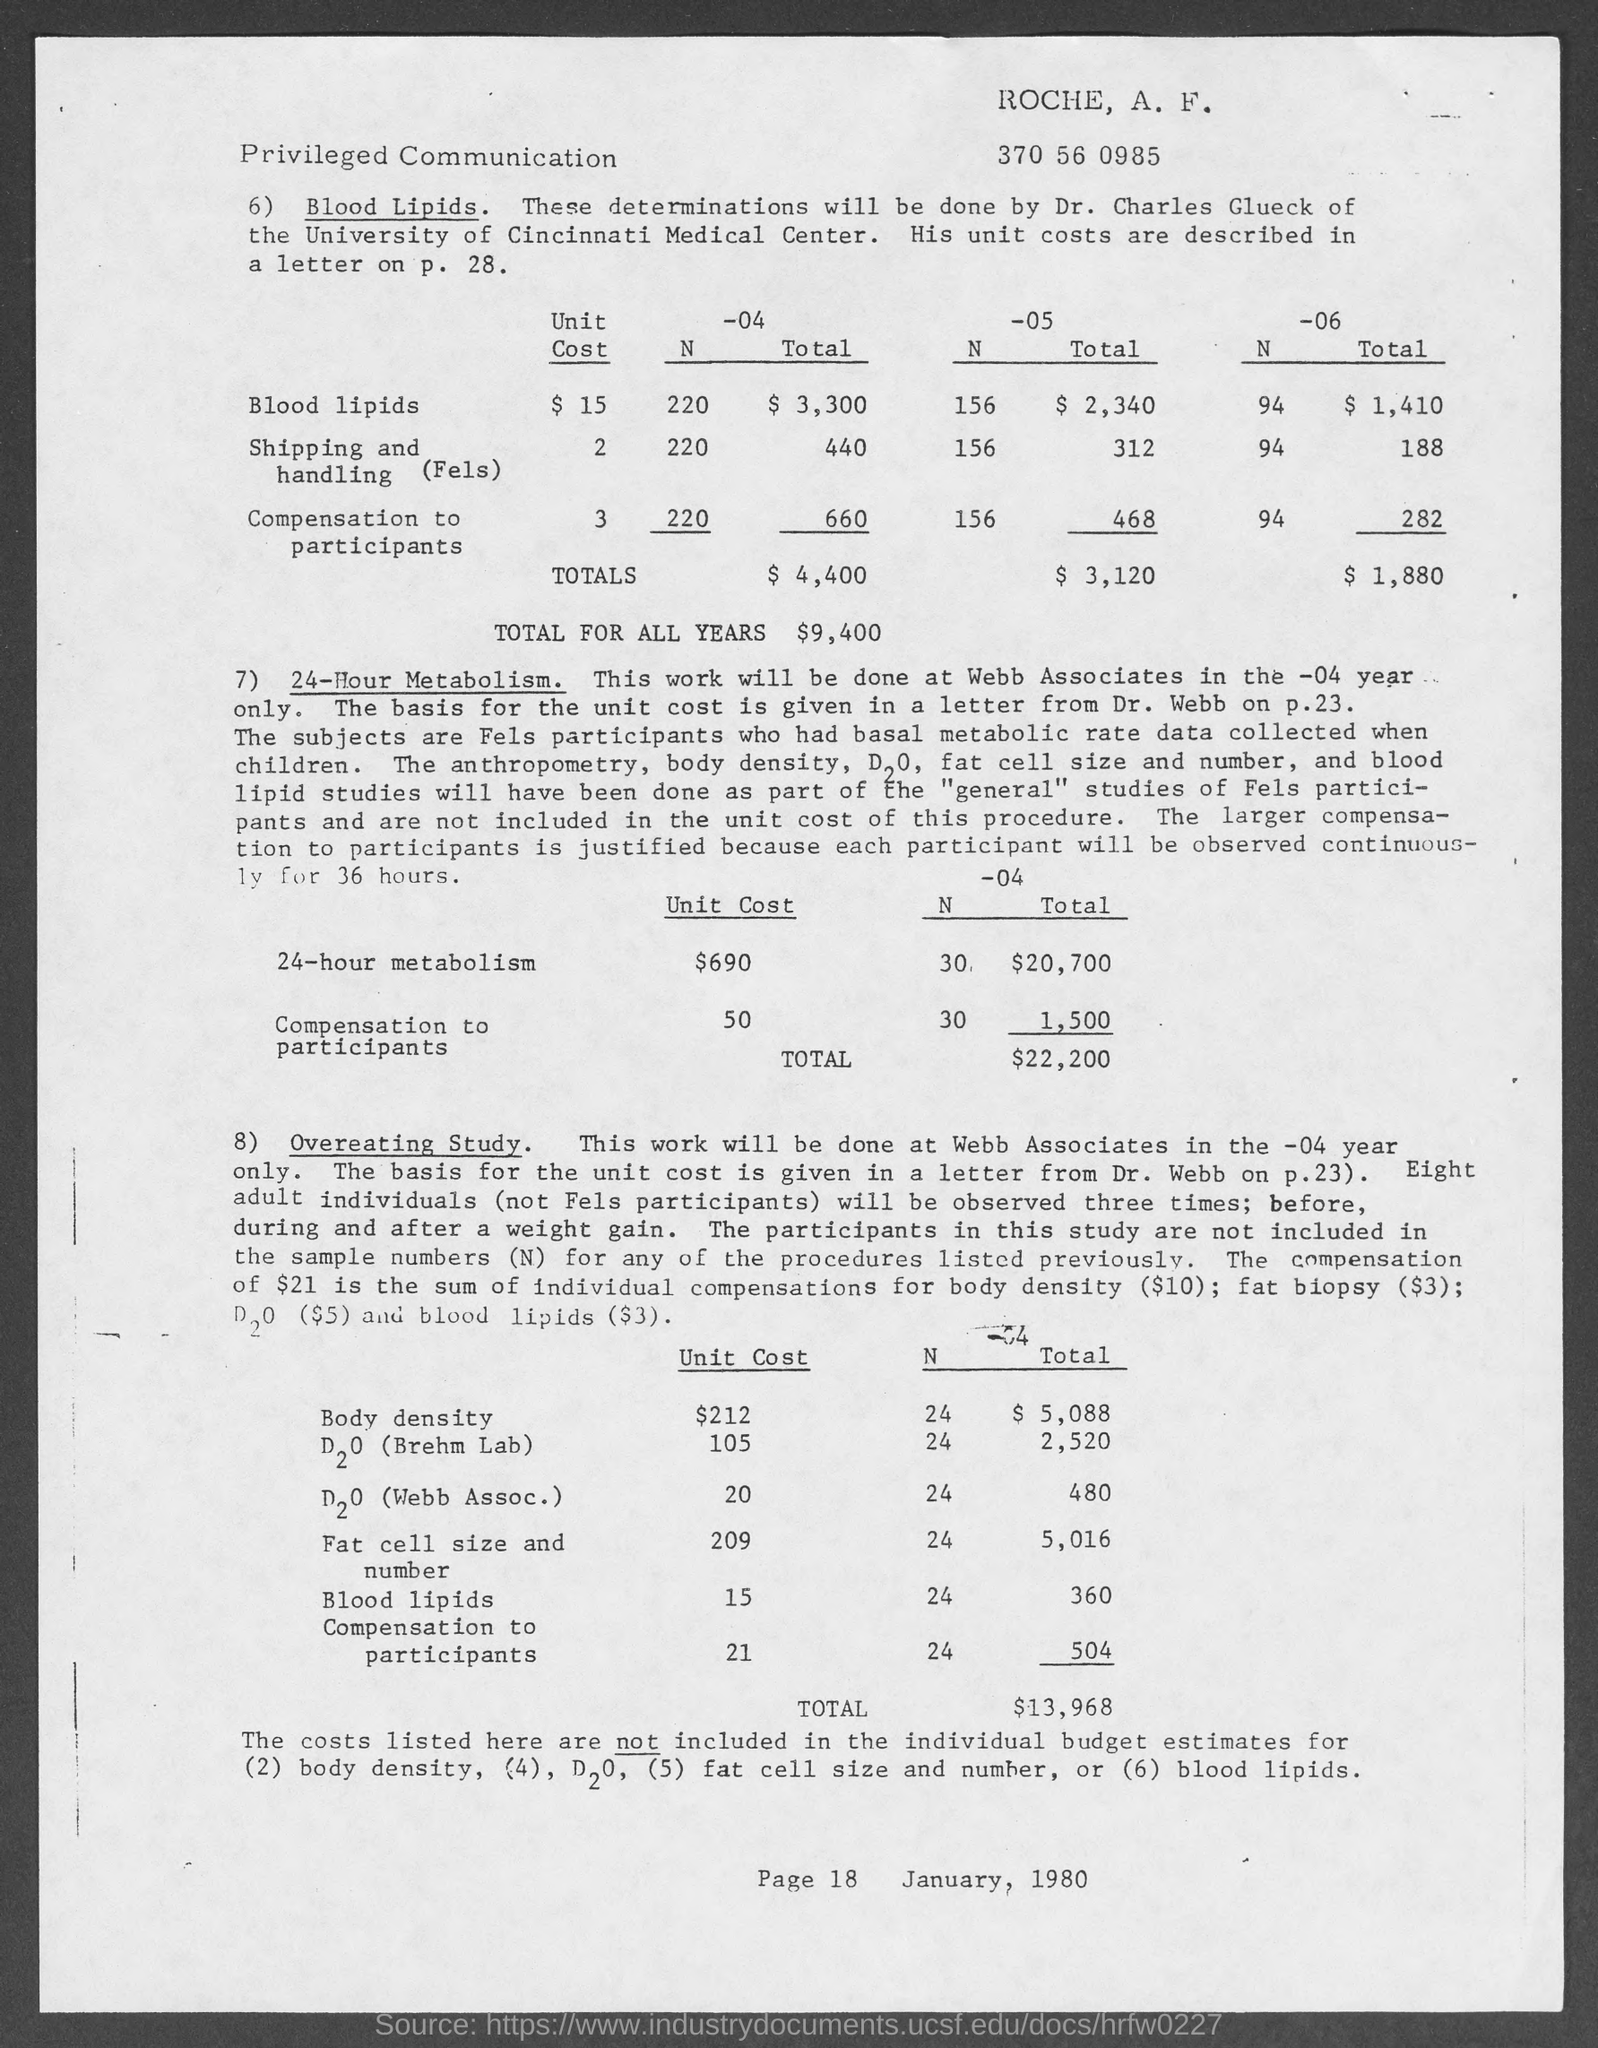Highlight a few significant elements in this photo. The unit cost for 24-hour Metabolism is $690. The page number is 18, as declared on page 18. The unit cost for body density is $212. The total for all years is $9,400. The date on the document is January 1980. 